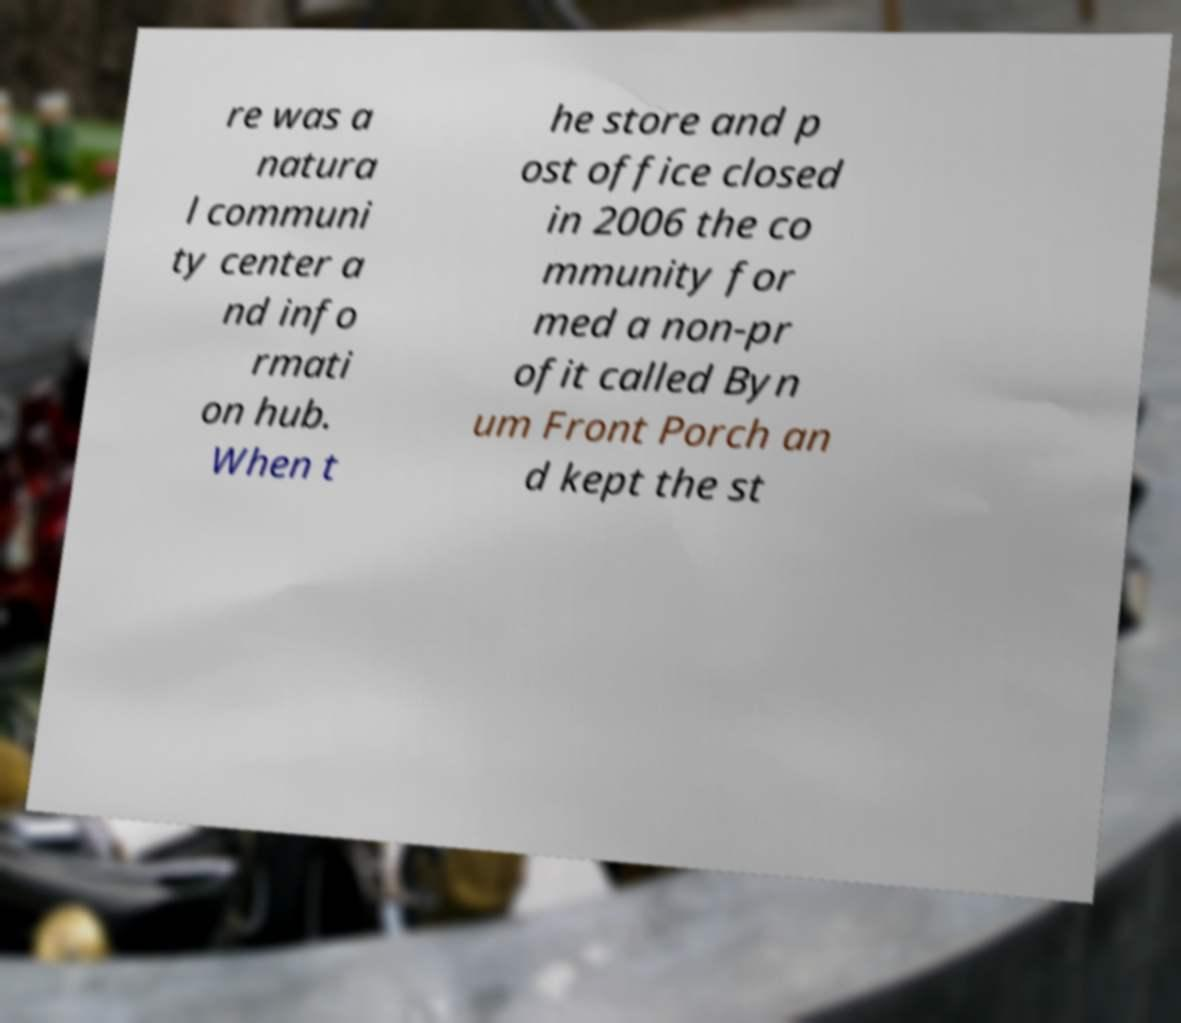Could you extract and type out the text from this image? re was a natura l communi ty center a nd info rmati on hub. When t he store and p ost office closed in 2006 the co mmunity for med a non-pr ofit called Byn um Front Porch an d kept the st 